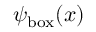Convert formula to latex. <formula><loc_0><loc_0><loc_500><loc_500>\psi _ { b o x } ( x )</formula> 